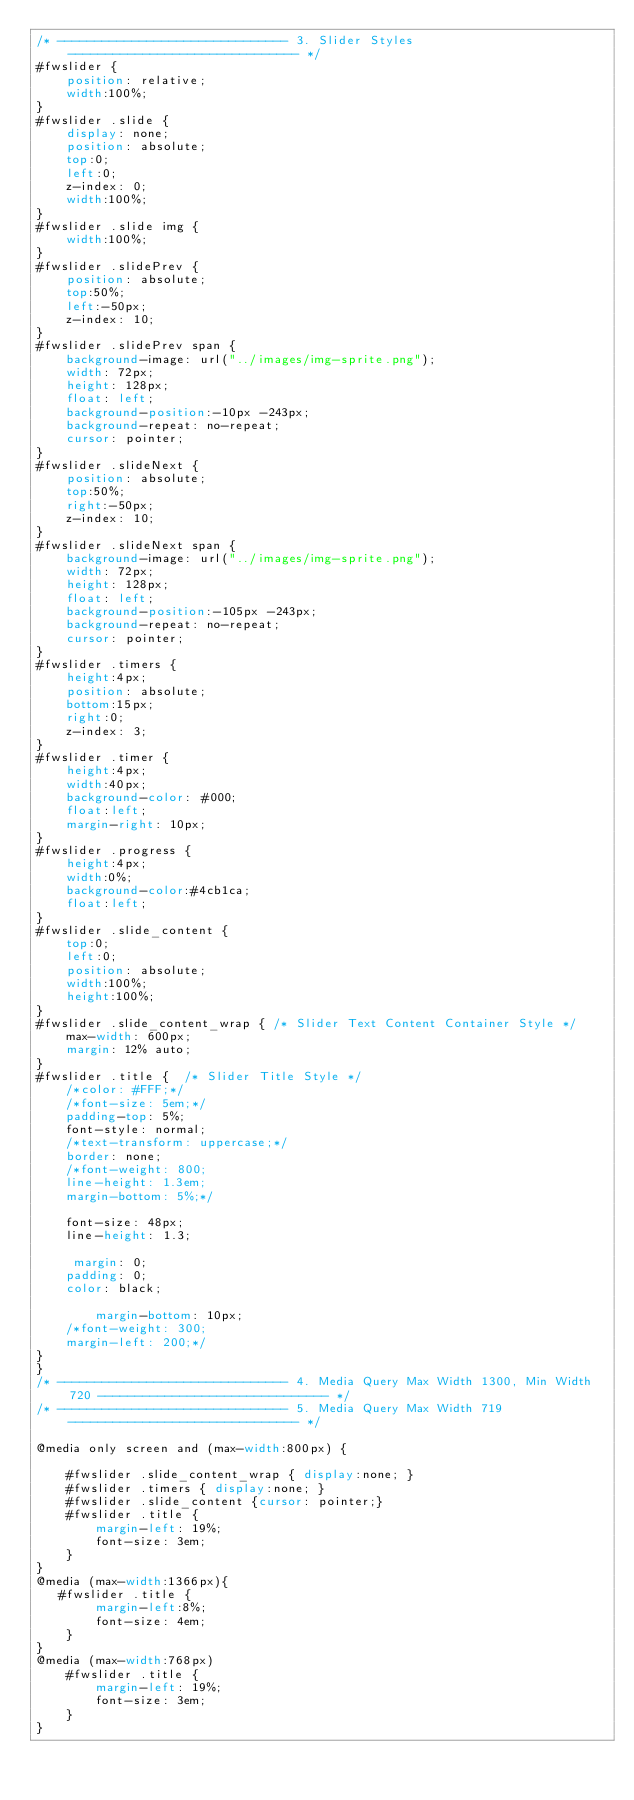Convert code to text. <code><loc_0><loc_0><loc_500><loc_500><_CSS_>/* ------------------------------- 3. Slider Styles ------------------------------- */
#fwslider {
    position: relative;
    width:100%;
}
#fwslider .slide {
    display: none;
    position: absolute;
    top:0;
    left:0;
    z-index: 0;
    width:100%;
}
#fwslider .slide img {
    width:100%;
}
#fwslider .slidePrev {
  	position: absolute;
    top:50%;
    left:-50px;
    z-index: 10;
}
#fwslider .slidePrev span {
	background-image: url("../images/img-sprite.png");
	width: 72px;
	height: 128px;
	float: left;
	background-position:-10px -243px;
	background-repeat: no-repeat;
	cursor: pointer;
}
#fwslider .slideNext {
   	position: absolute;
    top:50%;
    right:-50px;
   	z-index: 10;
}
#fwslider .slideNext span {
 	background-image: url("../images/img-sprite.png");
	width: 72px;
	height: 128px;
	float: left;
	background-position:-105px -243px;
	background-repeat: no-repeat;
	cursor: pointer;
}
#fwslider .timers {
    height:4px;
    position: absolute;
    bottom:15px;
    right:0;
    z-index: 3;
}
#fwslider .timer {
    height:4px;
    width:40px;
    background-color: #000;
    float:left;
    margin-right: 10px;
}
#fwslider .progress {
    height:4px;
    width:0%;
    background-color:#4cb1ca;
    float:left;
}
#fwslider .slide_content {
    top:0;
    left:0;
    position: absolute;
    width:100%;
    height:100%;
}
#fwslider .slide_content_wrap { /* Slider Text Content Container Style */
    max-width: 600px;
	margin: 12% auto;
}
#fwslider .title {  /* Slider Title Style */
	/*color: #FFF;*/
	/*font-size: 5em;*/
	padding-top: 5%;
	font-style: normal;
	/*text-transform: uppercase;*/
	border: none;
	/*font-weight: 800;
	line-height: 1.3em;
	margin-bottom: 5%;*/

    font-size: 48px;
    line-height: 1.3;

     margin: 0;
    padding: 0;
    color: black;

        margin-bottom: 10px;
    /*font-weight: 300;
    margin-left: 200;*/
}
}
/* ------------------------------- 4. Media Query Max Width 1300, Min Width 720 ------------------------------- */
/* ------------------------------- 5. Media Query Max Width 719 ------------------------------- */

@media only screen and (max-width:800px) {

    #fwslider .slide_content_wrap { display:none; }
    #fwslider .timers { display:none; }
    #fwslider .slide_content {cursor: pointer;}
	#fwslider .title {
		margin-left: 19%;
		font-size: 3em;
	}
}
@media (max-width:1366px){
   #fwslider .title {
		margin-left:8%;
		font-size: 4em;
	}
}
@media (max-width:768px)
	#fwslider .title {
		margin-left: 19%;
		font-size: 3em;
	}
}
</code> 